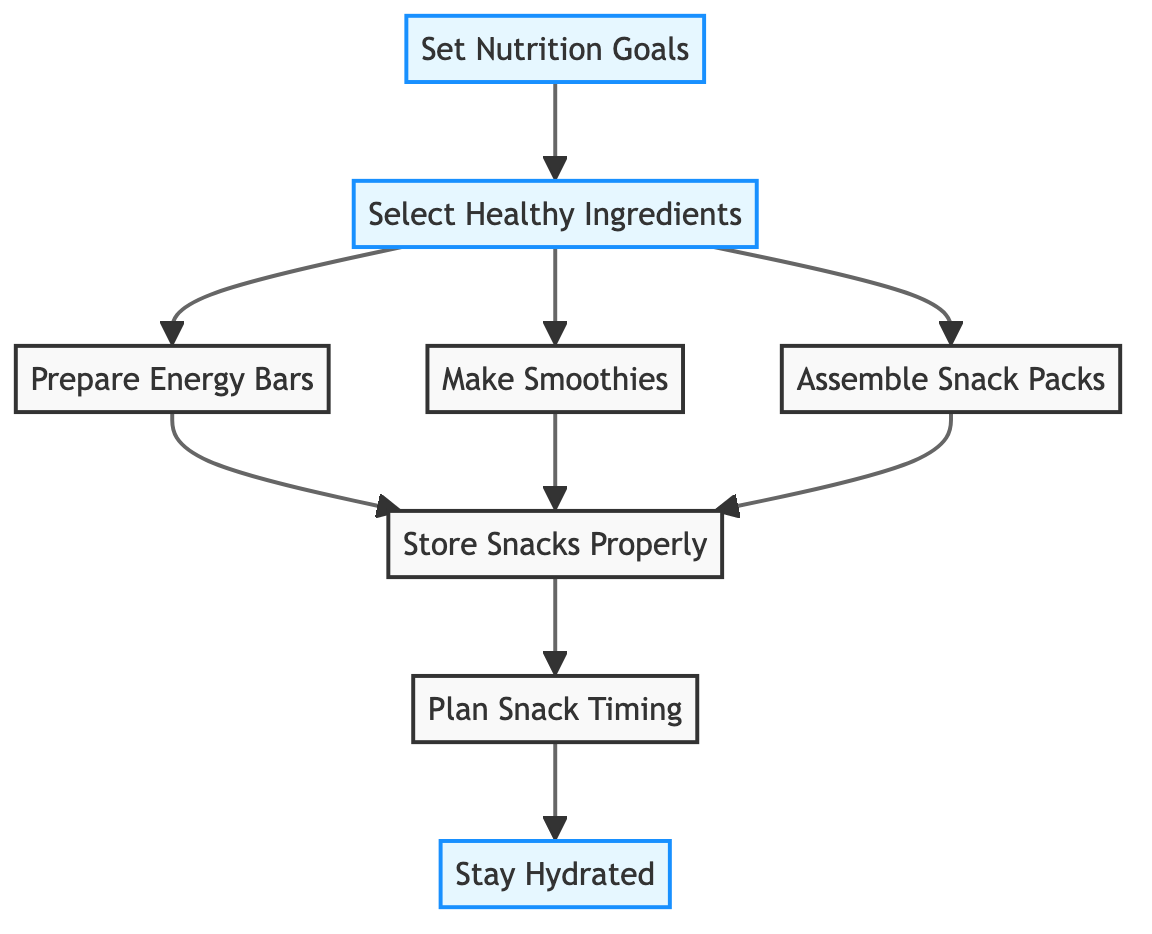What is the first step in the process? The first step is indicated by the node labeled "Set Nutrition Goals". This node connects to the next step, which is "Select Healthy Ingredients".
Answer: Set Nutrition Goals How many steps are there in total? The diagram lists a total of eight steps, which includes the final step, "Stay Hydrated".
Answer: Eight What ingredient options are included in the step "Select Healthy Ingredients"? The step connects to other options, but specifically mentions ingredients like hummus, whole grain bread, fruits, and nuts as healthy choices.
Answer: Hummus, whole grain bread, fruits, and nuts Which steps lead to storing snacks properly? The steps that connect to "Store Snacks Properly" are "Prepare Energy Bars", "Make Smoothies", and "Assemble Snack Packs" as indicated in the diagram.
Answer: Prepare Energy Bars, Make Smoothies, Assemble Snack Packs What is the last step of the flowchart? The last step is shown as "Stay Hydrated", which follows the "Plan Snack Timing" node as the final action to ensure proper hydration.
Answer: Stay Hydrated What is emphasized in the step "Plan Snack Timing"? This step highlights the importance of scheduling snack breaks to maintain energy levels, indicating that timing is crucial for performance during rehearsals.
Answer: Snack breaks What is necessary for proper storage of snacks? The diagram highlights the need to use appropriate containers and the refrigeration of perishable items as key steps to maintain freshness and safety.
Answer: Appropriate containers and refrigeration How does "Set Nutrition Goals" connect to "Stay Hydrated"? The connection from "Set Nutrition Goals" to "Stay Hydrated" is indirect; it influences all following steps that lead to proper nutrition and hydration, culminating in "Stay Hydrated" as the final step.
Answer: Indirectly through all steps 